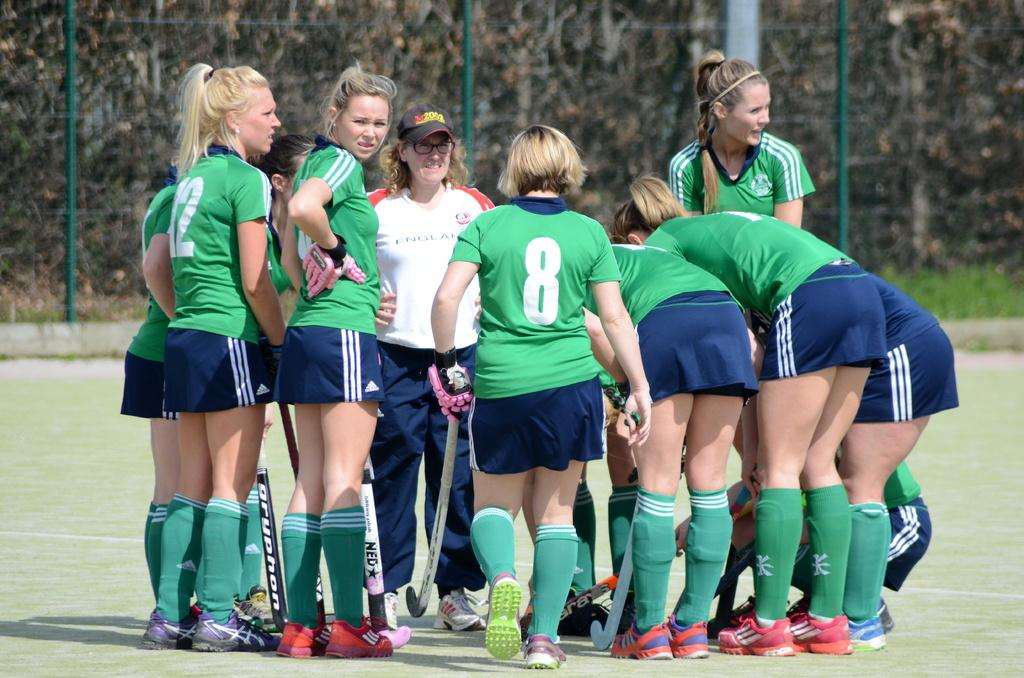Provide a one-sentence caption for the provided image. Player 8 walking up her other team member already in a group. 